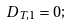Convert formula to latex. <formula><loc_0><loc_0><loc_500><loc_500>D _ { T , 1 } = 0 ;</formula> 